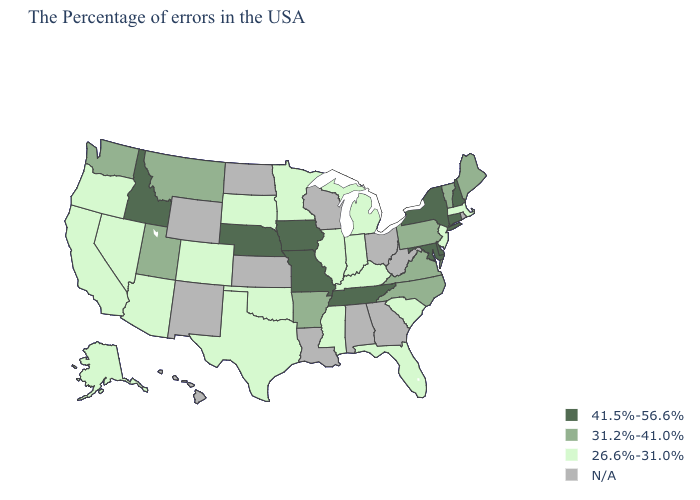What is the value of Tennessee?
Answer briefly. 41.5%-56.6%. What is the lowest value in the USA?
Quick response, please. 26.6%-31.0%. Does New Hampshire have the highest value in the USA?
Short answer required. Yes. Name the states that have a value in the range 26.6%-31.0%?
Be succinct. Massachusetts, New Jersey, South Carolina, Florida, Michigan, Kentucky, Indiana, Illinois, Mississippi, Minnesota, Oklahoma, Texas, South Dakota, Colorado, Arizona, Nevada, California, Oregon, Alaska. Does Nebraska have the lowest value in the USA?
Quick response, please. No. Does Nebraska have the highest value in the MidWest?
Be succinct. Yes. Which states hav the highest value in the South?
Give a very brief answer. Delaware, Maryland, Tennessee. What is the value of West Virginia?
Give a very brief answer. N/A. What is the lowest value in states that border New Jersey?
Short answer required. 31.2%-41.0%. Is the legend a continuous bar?
Give a very brief answer. No. Does Missouri have the highest value in the USA?
Keep it brief. Yes. What is the highest value in the USA?
Keep it brief. 41.5%-56.6%. Which states hav the highest value in the South?
Short answer required. Delaware, Maryland, Tennessee. 